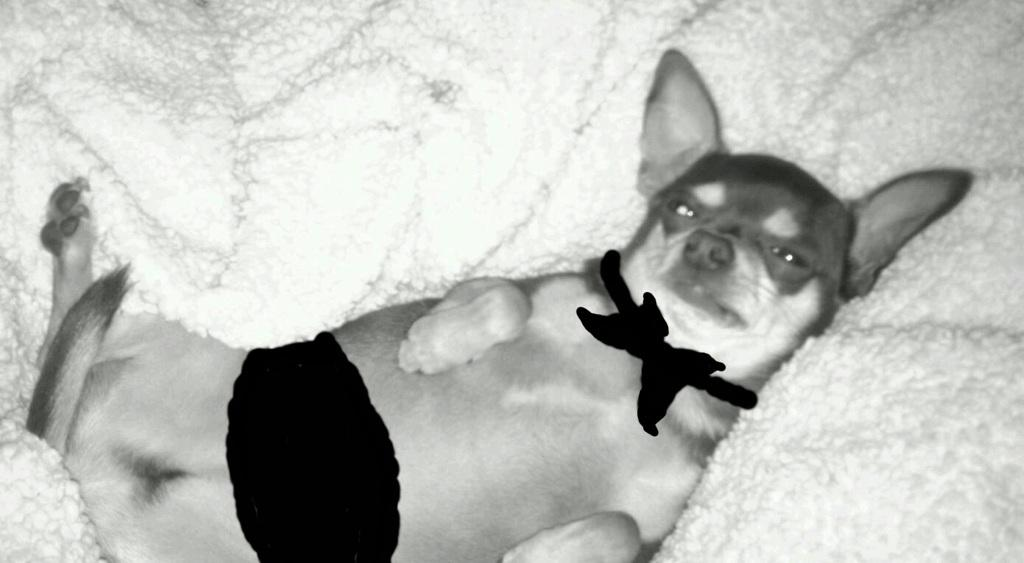What type of animal is present in the image? There is a dog in the image. What is the dog lying on? The dog is lying on a white object. Can you describe any additional features on the dog? There are black animated marks on the dog. How does the dog use the hammer in the image? There is no hammer present in the image, so the dog cannot use it. 